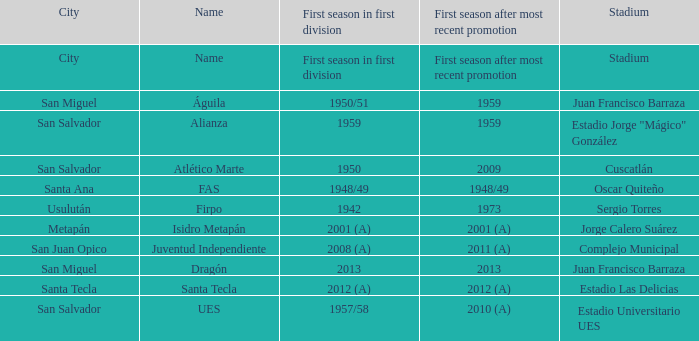Which city is Alianza? San Salvador. 